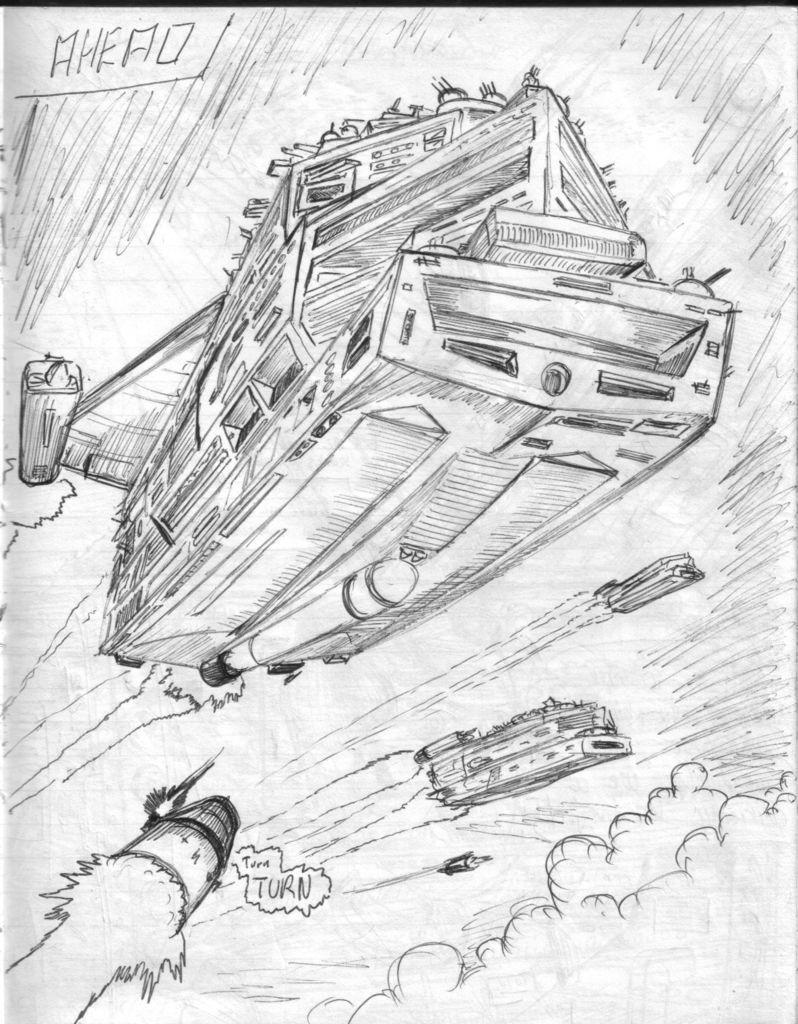Can you describe this image briefly? In this picture I can see a drawing of spaceships in the sky, on the paper. 